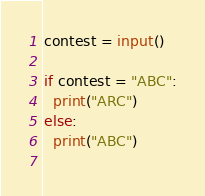<code> <loc_0><loc_0><loc_500><loc_500><_Python_>contest = input()

if contest = "ABC":
  print("ARC")
else:
  print("ABC")
  </code> 